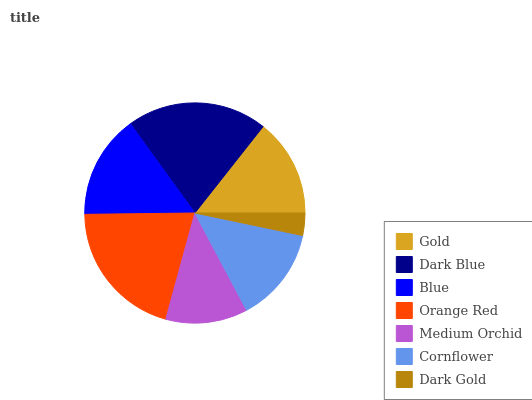Is Dark Gold the minimum?
Answer yes or no. Yes. Is Dark Blue the maximum?
Answer yes or no. Yes. Is Blue the minimum?
Answer yes or no. No. Is Blue the maximum?
Answer yes or no. No. Is Dark Blue greater than Blue?
Answer yes or no. Yes. Is Blue less than Dark Blue?
Answer yes or no. Yes. Is Blue greater than Dark Blue?
Answer yes or no. No. Is Dark Blue less than Blue?
Answer yes or no. No. Is Gold the high median?
Answer yes or no. Yes. Is Gold the low median?
Answer yes or no. Yes. Is Dark Blue the high median?
Answer yes or no. No. Is Blue the low median?
Answer yes or no. No. 